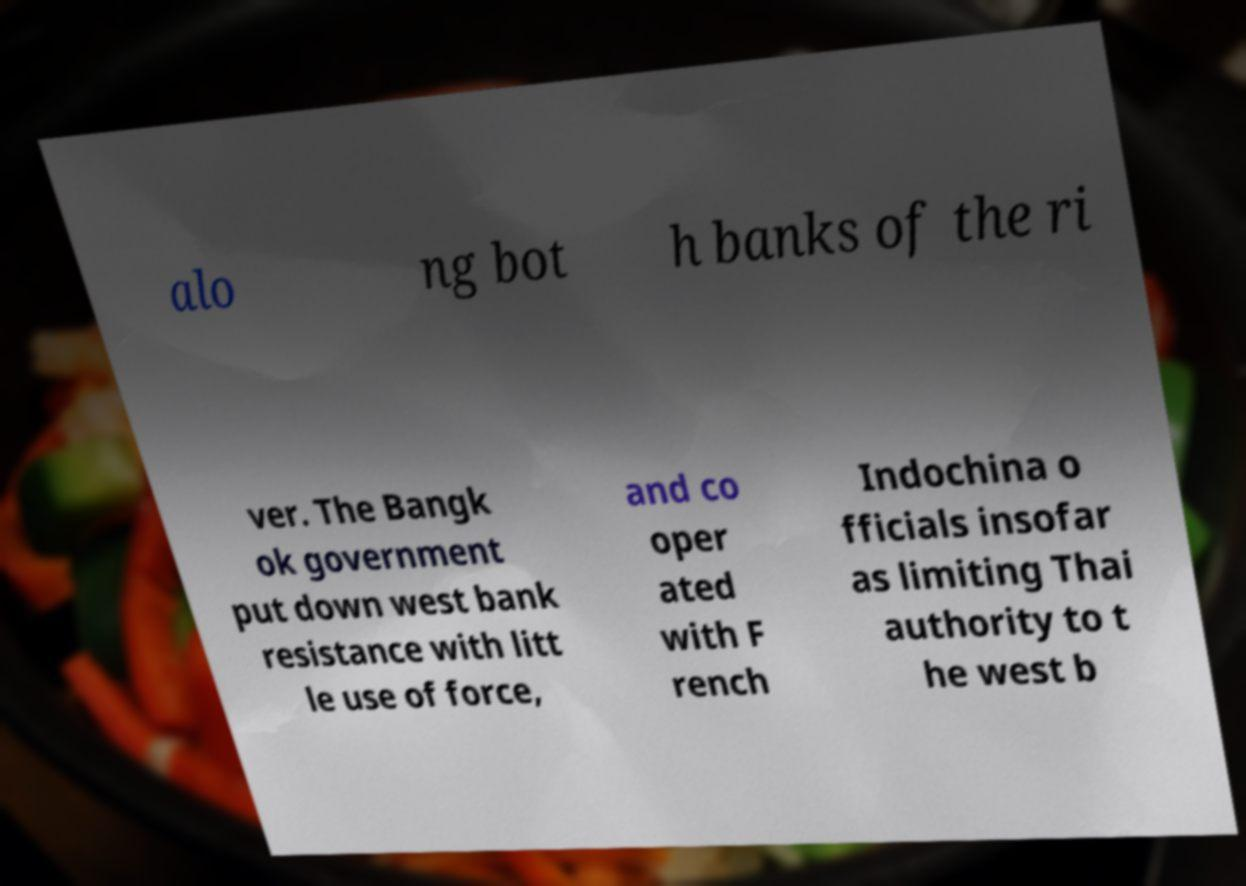Please read and relay the text visible in this image. What does it say? alo ng bot h banks of the ri ver. The Bangk ok government put down west bank resistance with litt le use of force, and co oper ated with F rench Indochina o fficials insofar as limiting Thai authority to t he west b 